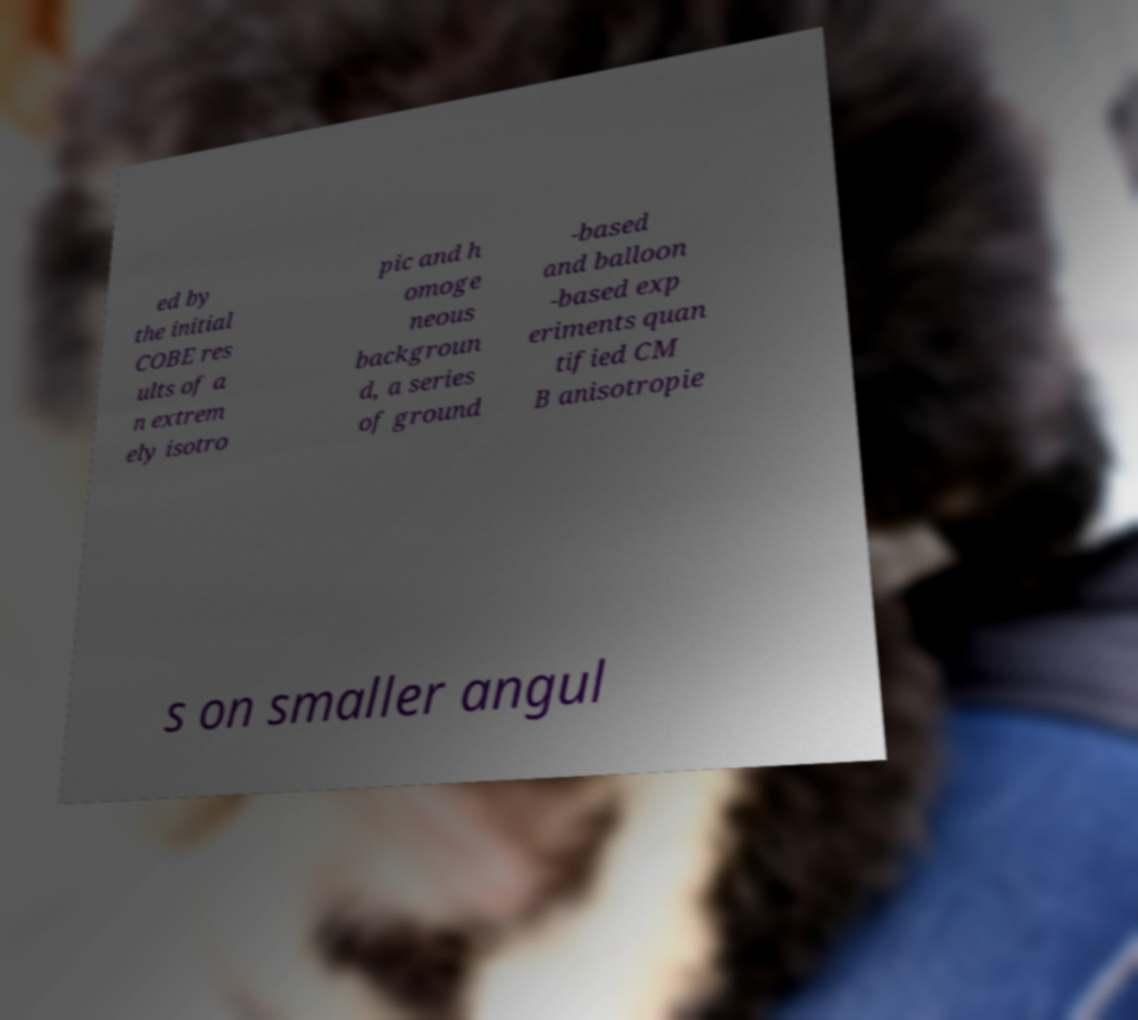Can you read and provide the text displayed in the image?This photo seems to have some interesting text. Can you extract and type it out for me? ed by the initial COBE res ults of a n extrem ely isotro pic and h omoge neous backgroun d, a series of ground -based and balloon -based exp eriments quan tified CM B anisotropie s on smaller angul 